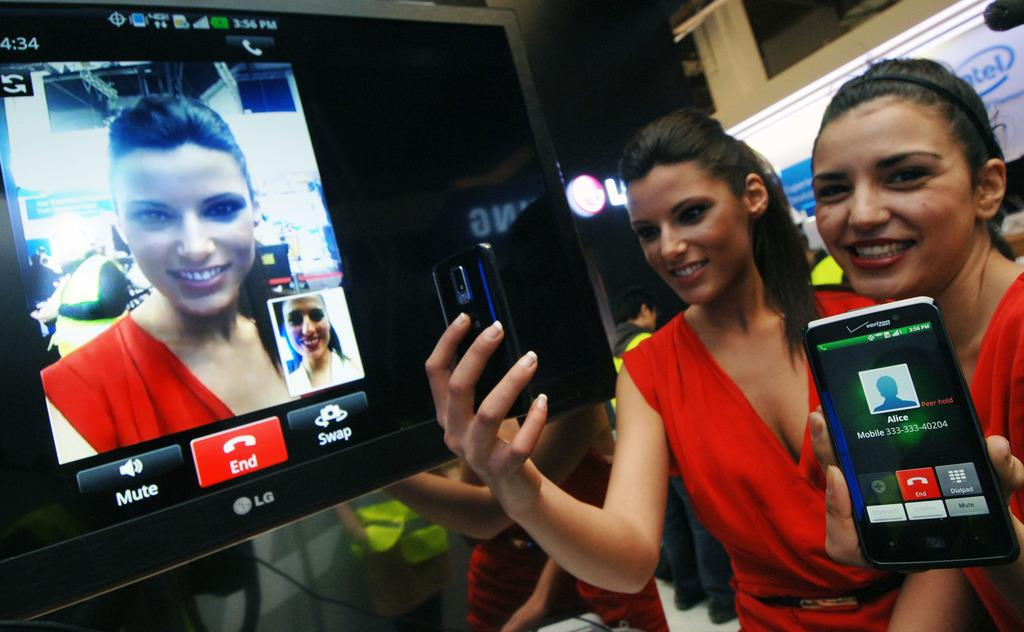How many people are in the image? There are two women in the image. What are the women doing in the image? The women are standing and holding mobiles in their hands. What is visible on the screen in the image? The information about the screen is not provided in the facts. What is on the back of the women? There is a hoarding on the back of the women. What flavor of destruction can be seen in the image? There is no destruction or flavor present in the image; it features two women standing and holding mobiles. 